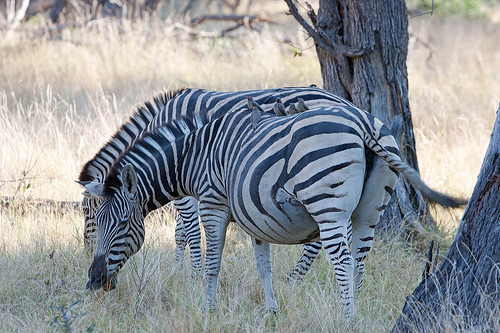What are the zebras doing in this image? The zebras appear to be grazing in the savannah. Their heads are down, which suggests they are eating the grass, a common behavior for zebras who feed mostly on this type of vegetation. 